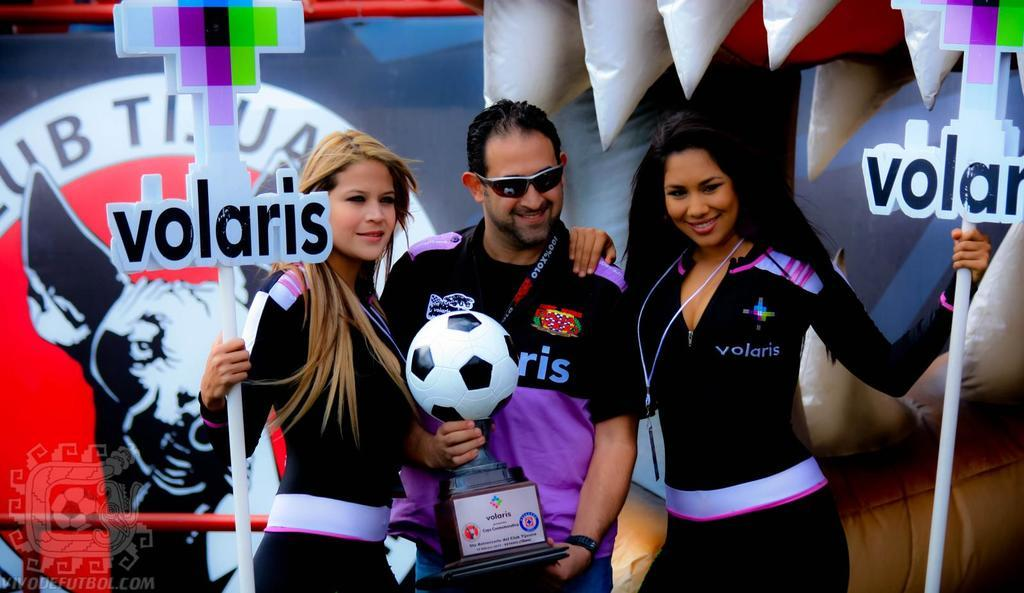<image>
Offer a succinct explanation of the picture presented. People posing for a photo with a woman wearing a jacket which says volaris on it. 